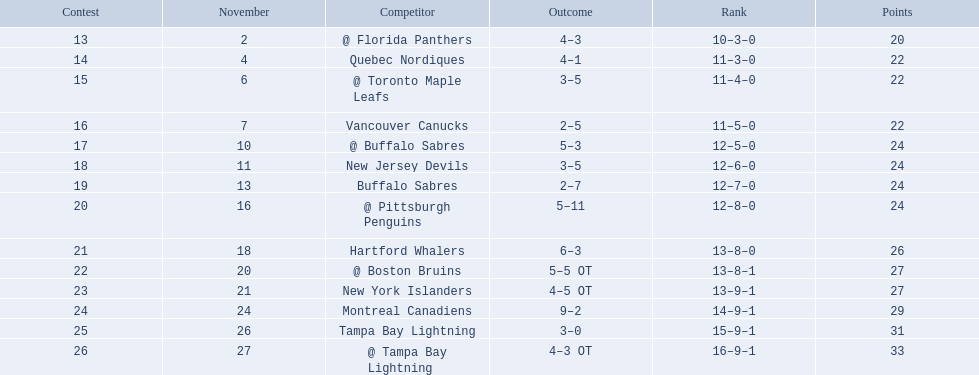What were the scores? @ Florida Panthers, 4–3, Quebec Nordiques, 4–1, @ Toronto Maple Leafs, 3–5, Vancouver Canucks, 2–5, @ Buffalo Sabres, 5–3, New Jersey Devils, 3–5, Buffalo Sabres, 2–7, @ Pittsburgh Penguins, 5–11, Hartford Whalers, 6–3, @ Boston Bruins, 5–5 OT, New York Islanders, 4–5 OT, Montreal Canadiens, 9–2, Tampa Bay Lightning, 3–0, @ Tampa Bay Lightning, 4–3 OT. What score was the closest? New York Islanders, 4–5 OT. What team had that score? New York Islanders. 